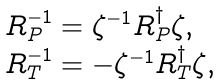Convert formula to latex. <formula><loc_0><loc_0><loc_500><loc_500>\begin{array} { l } R _ { P } ^ { - 1 } = \zeta ^ { - 1 } R _ { P } ^ { \dagger } \zeta , \\ R _ { T } ^ { - 1 } = - \zeta ^ { - 1 } R _ { T } ^ { \dagger } \zeta , \end{array}</formula> 